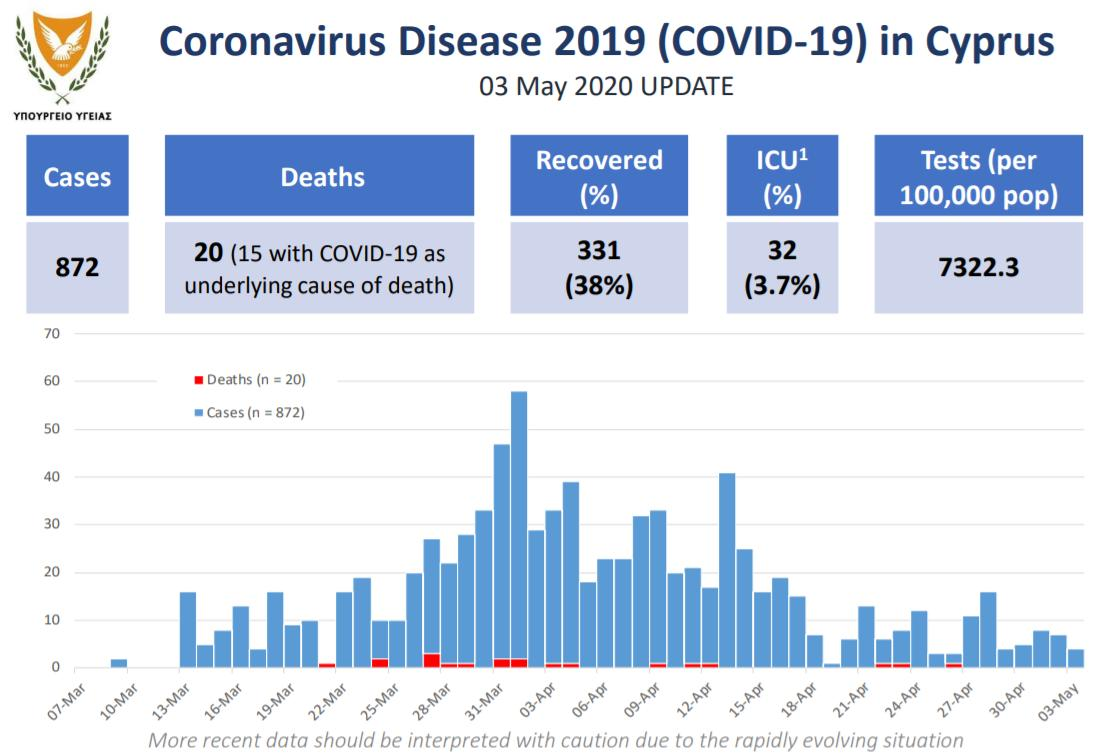List a handful of essential elements in this visual. As of 03 May, 2020, the total number of COVID-19 cases reported in Cyprus was 872. As of May 3, 2020, Cyprus reported 20 COVID-19 deaths. On May 3, 2020, the number of COVID-19 tests per million population performed in Cyprus was 7,322.3. As of May 3, 2020, a total of 32 COVID-19 patients had been admitted to ICU in Cyprus. As of 03 May, 2020, the number of recovered COVID-19 cases reported in Cyprus is 331. 